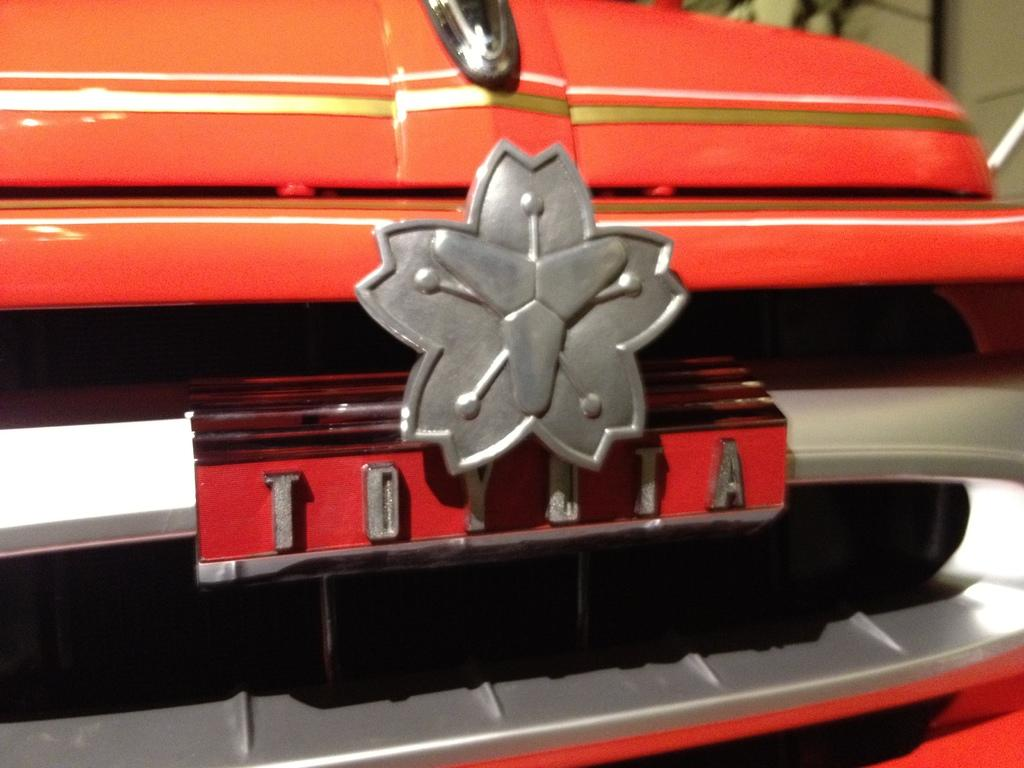What is the main subject of the image? The main subject of the image is an emblem. Where is the emblem located? The emblem is on a board attached to a vehicle in the image. Can you describe the background of the image? The background of the image is blurry. How many eyes can be seen on the celery in the image? There is no celery present in the image, and therefore no eyes can be seen on it. 